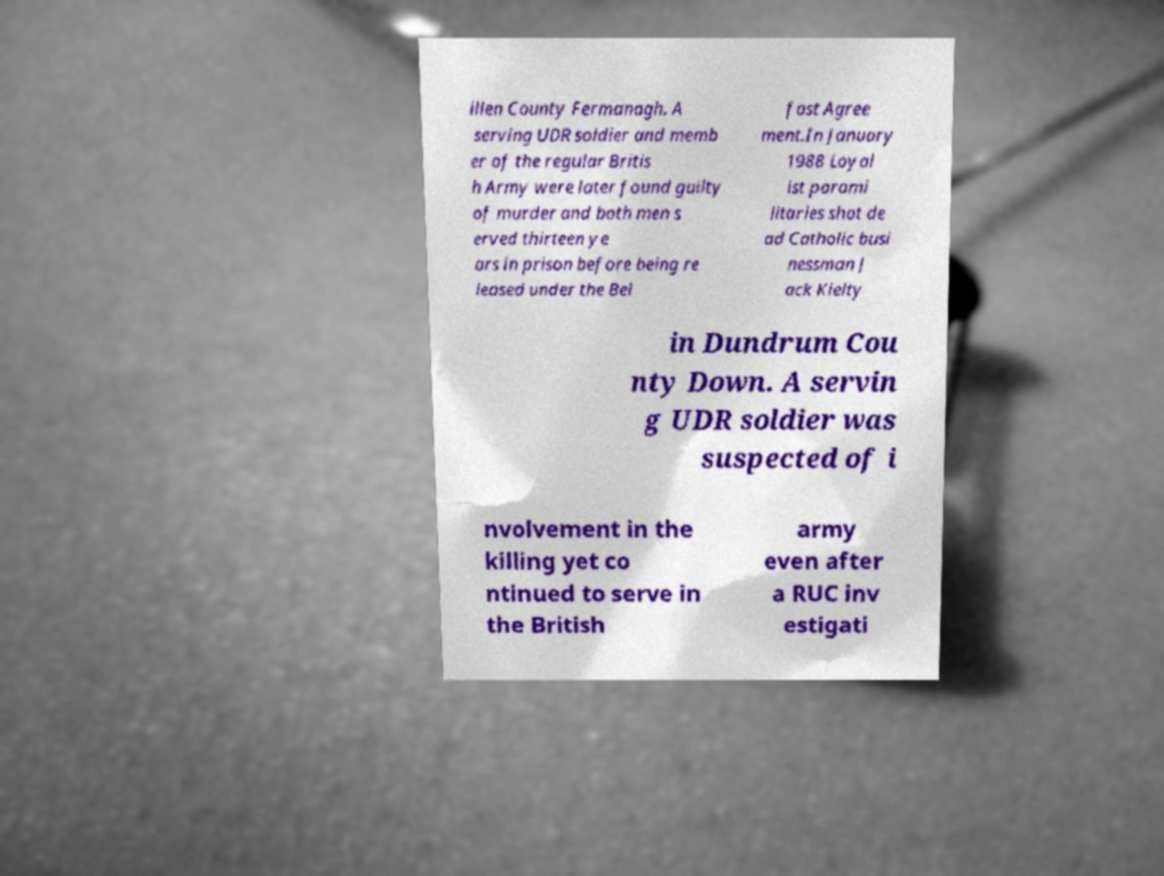Can you read and provide the text displayed in the image?This photo seems to have some interesting text. Can you extract and type it out for me? illen County Fermanagh. A serving UDR soldier and memb er of the regular Britis h Army were later found guilty of murder and both men s erved thirteen ye ars in prison before being re leased under the Bel fast Agree ment.In January 1988 Loyal ist parami litaries shot de ad Catholic busi nessman J ack Kielty in Dundrum Cou nty Down. A servin g UDR soldier was suspected of i nvolvement in the killing yet co ntinued to serve in the British army even after a RUC inv estigati 